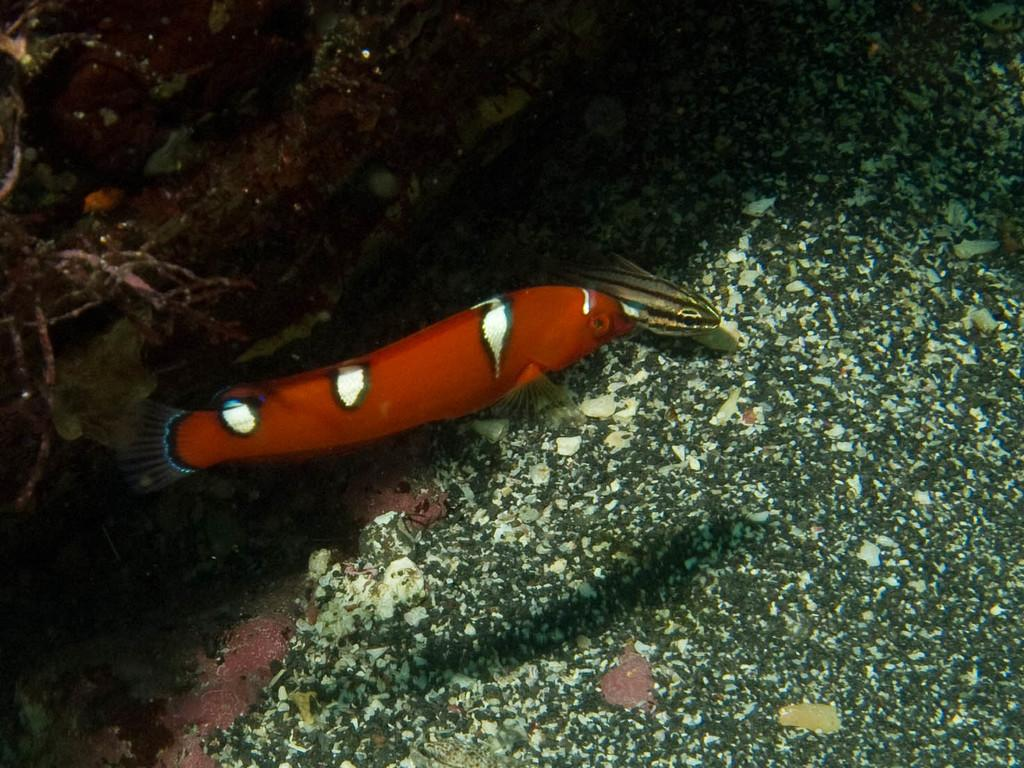What type of animal can be seen in the water in the image? There is a fish in the water in the image. What can be seen on the left side of the image? There are water plants on the left side of the image. What type of music can be heard playing in the background of the image? There is no music present in the image, as it features a fish in the water and water plants. How many pigs can be seen in the image? There are no pigs present in the image. 